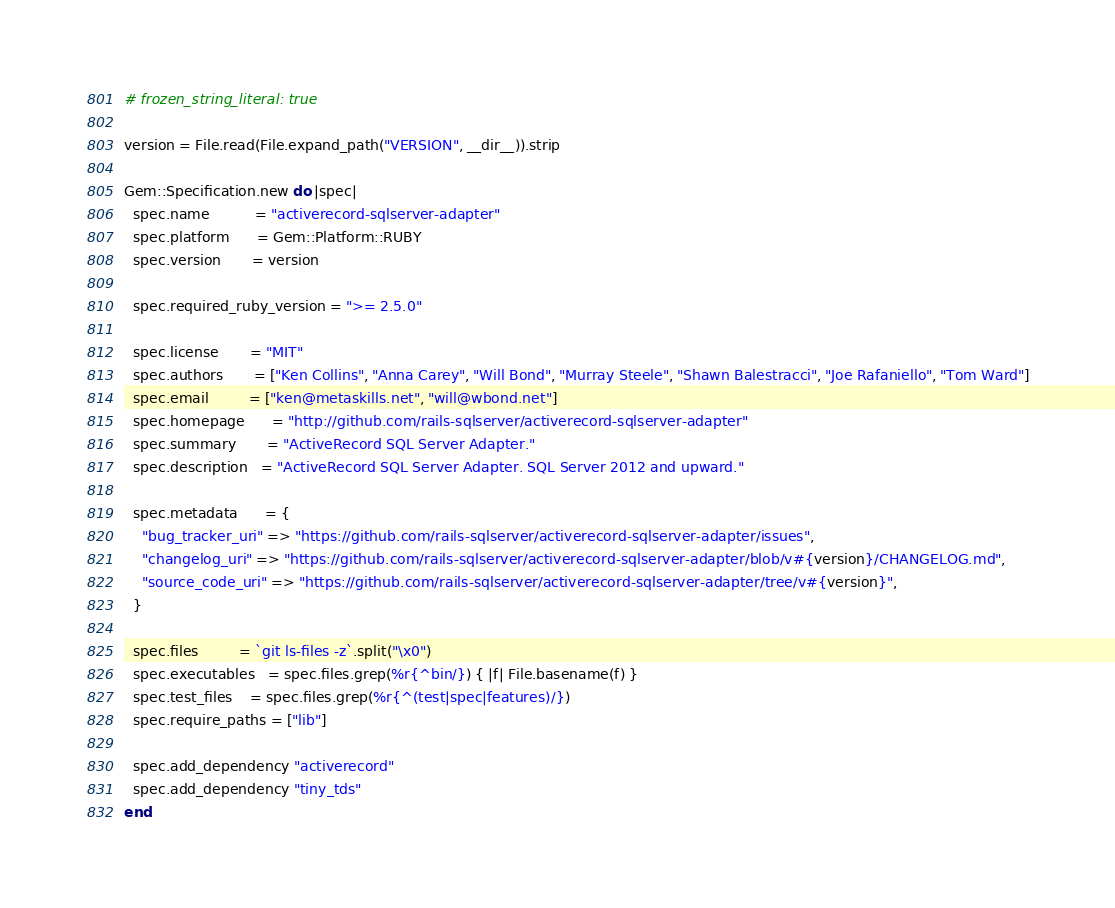<code> <loc_0><loc_0><loc_500><loc_500><_Ruby_># frozen_string_literal: true

version = File.read(File.expand_path("VERSION", __dir__)).strip

Gem::Specification.new do |spec|
  spec.name          = "activerecord-sqlserver-adapter"
  spec.platform      = Gem::Platform::RUBY
  spec.version       = version

  spec.required_ruby_version = ">= 2.5.0"

  spec.license       = "MIT"
  spec.authors       = ["Ken Collins", "Anna Carey", "Will Bond", "Murray Steele", "Shawn Balestracci", "Joe Rafaniello", "Tom Ward"]
  spec.email         = ["ken@metaskills.net", "will@wbond.net"]
  spec.homepage      = "http://github.com/rails-sqlserver/activerecord-sqlserver-adapter"
  spec.summary       = "ActiveRecord SQL Server Adapter."
  spec.description   = "ActiveRecord SQL Server Adapter. SQL Server 2012 and upward."

  spec.metadata      = {
    "bug_tracker_uri" => "https://github.com/rails-sqlserver/activerecord-sqlserver-adapter/issues",
    "changelog_uri" => "https://github.com/rails-sqlserver/activerecord-sqlserver-adapter/blob/v#{version}/CHANGELOG.md",
    "source_code_uri" => "https://github.com/rails-sqlserver/activerecord-sqlserver-adapter/tree/v#{version}",
  }

  spec.files         = `git ls-files -z`.split("\x0")
  spec.executables   = spec.files.grep(%r{^bin/}) { |f| File.basename(f) }
  spec.test_files    = spec.files.grep(%r{^(test|spec|features)/})
  spec.require_paths = ["lib"]

  spec.add_dependency "activerecord"
  spec.add_dependency "tiny_tds"
end
</code> 